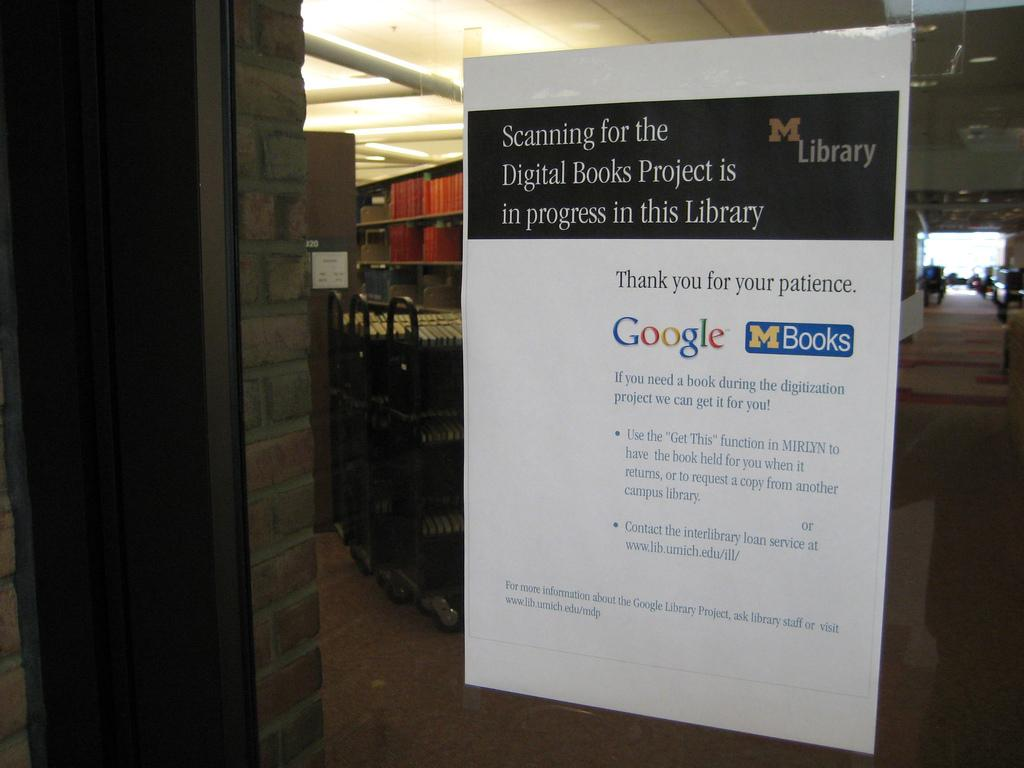<image>
Create a compact narrative representing the image presented. M Books from Google are shown on this advert in the window of the library. 